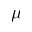<formula> <loc_0><loc_0><loc_500><loc_500>\mu</formula> 